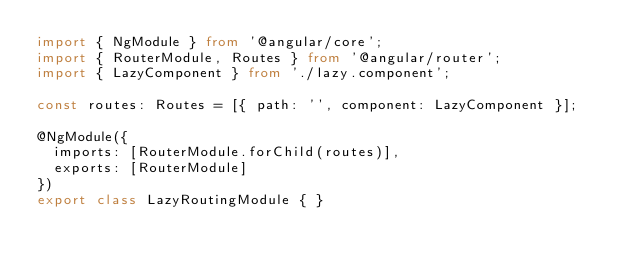Convert code to text. <code><loc_0><loc_0><loc_500><loc_500><_TypeScript_>import { NgModule } from '@angular/core';
import { RouterModule, Routes } from '@angular/router';
import { LazyComponent } from './lazy.component';

const routes: Routes = [{ path: '', component: LazyComponent }];

@NgModule({
  imports: [RouterModule.forChild(routes)],
  exports: [RouterModule]
})
export class LazyRoutingModule { }
</code> 